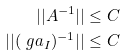Convert formula to latex. <formula><loc_0><loc_0><loc_500><loc_500>| | A ^ { - 1 } | | & \leq C \\ | | ( \ g a _ { I } ) ^ { - 1 } | | & \leq C</formula> 